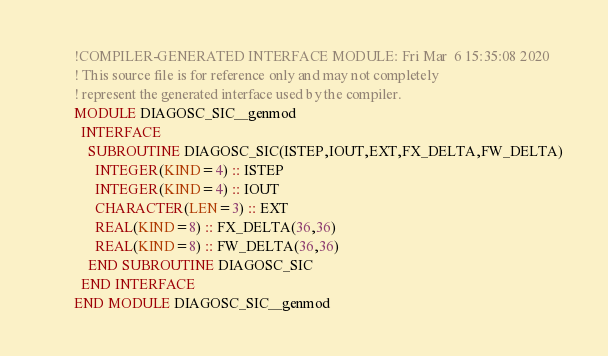Convert code to text. <code><loc_0><loc_0><loc_500><loc_500><_FORTRAN_>        !COMPILER-GENERATED INTERFACE MODULE: Fri Mar  6 15:35:08 2020
        ! This source file is for reference only and may not completely
        ! represent the generated interface used by the compiler.
        MODULE DIAGOSC_SIC__genmod
          INTERFACE 
            SUBROUTINE DIAGOSC_SIC(ISTEP,IOUT,EXT,FX_DELTA,FW_DELTA)
              INTEGER(KIND=4) :: ISTEP
              INTEGER(KIND=4) :: IOUT
              CHARACTER(LEN=3) :: EXT
              REAL(KIND=8) :: FX_DELTA(36,36)
              REAL(KIND=8) :: FW_DELTA(36,36)
            END SUBROUTINE DIAGOSC_SIC
          END INTERFACE 
        END MODULE DIAGOSC_SIC__genmod
</code> 